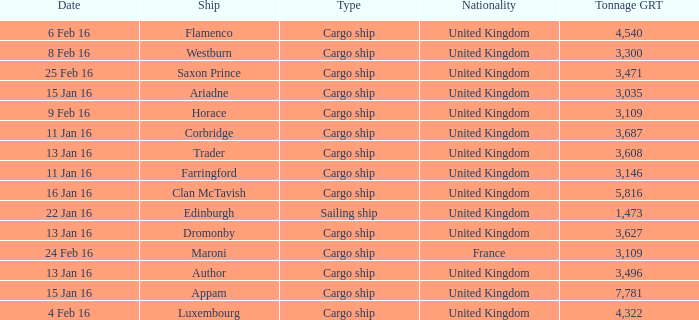Help me parse the entirety of this table. {'header': ['Date', 'Ship', 'Type', 'Nationality', 'Tonnage GRT'], 'rows': [['6 Feb 16', 'Flamenco', 'Cargo ship', 'United Kingdom', '4,540'], ['8 Feb 16', 'Westburn', 'Cargo ship', 'United Kingdom', '3,300'], ['25 Feb 16', 'Saxon Prince', 'Cargo ship', 'United Kingdom', '3,471'], ['15 Jan 16', 'Ariadne', 'Cargo ship', 'United Kingdom', '3,035'], ['9 Feb 16', 'Horace', 'Cargo ship', 'United Kingdom', '3,109'], ['11 Jan 16', 'Corbridge', 'Cargo ship', 'United Kingdom', '3,687'], ['13 Jan 16', 'Trader', 'Cargo ship', 'United Kingdom', '3,608'], ['11 Jan 16', 'Farringford', 'Cargo ship', 'United Kingdom', '3,146'], ['16 Jan 16', 'Clan McTavish', 'Cargo ship', 'United Kingdom', '5,816'], ['22 Jan 16', 'Edinburgh', 'Sailing ship', 'United Kingdom', '1,473'], ['13 Jan 16', 'Dromonby', 'Cargo ship', 'United Kingdom', '3,627'], ['24 Feb 16', 'Maroni', 'Cargo ship', 'France', '3,109'], ['13 Jan 16', 'Author', 'Cargo ship', 'United Kingdom', '3,496'], ['15 Jan 16', 'Appam', 'Cargo ship', 'United Kingdom', '7,781'], ['4 Feb 16', 'Luxembourg', 'Cargo ship', 'United Kingdom', '4,322']]} What is the nationality of the ship appam? United Kingdom. 